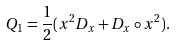<formula> <loc_0><loc_0><loc_500><loc_500>Q _ { 1 } = \frac { 1 } { 2 } ( x ^ { 2 } D _ { x } + D _ { x } \circ x ^ { 2 } ) .</formula> 